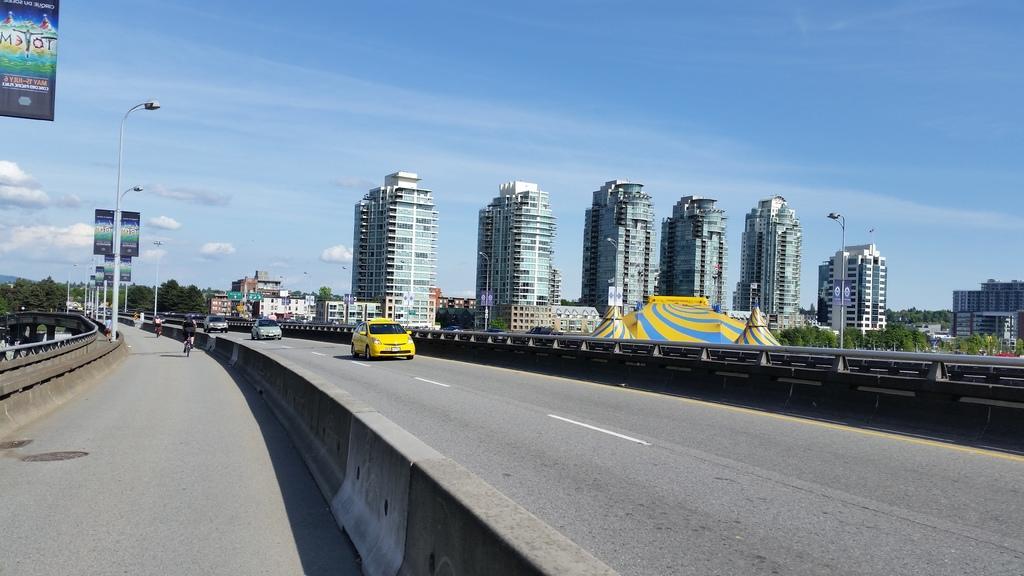Can you describe this image briefly? In this image on the road many vehicles are moving. In the background there are trees, buildings. On the side of the road there are street light, hoardings. The sky is cloudy. 